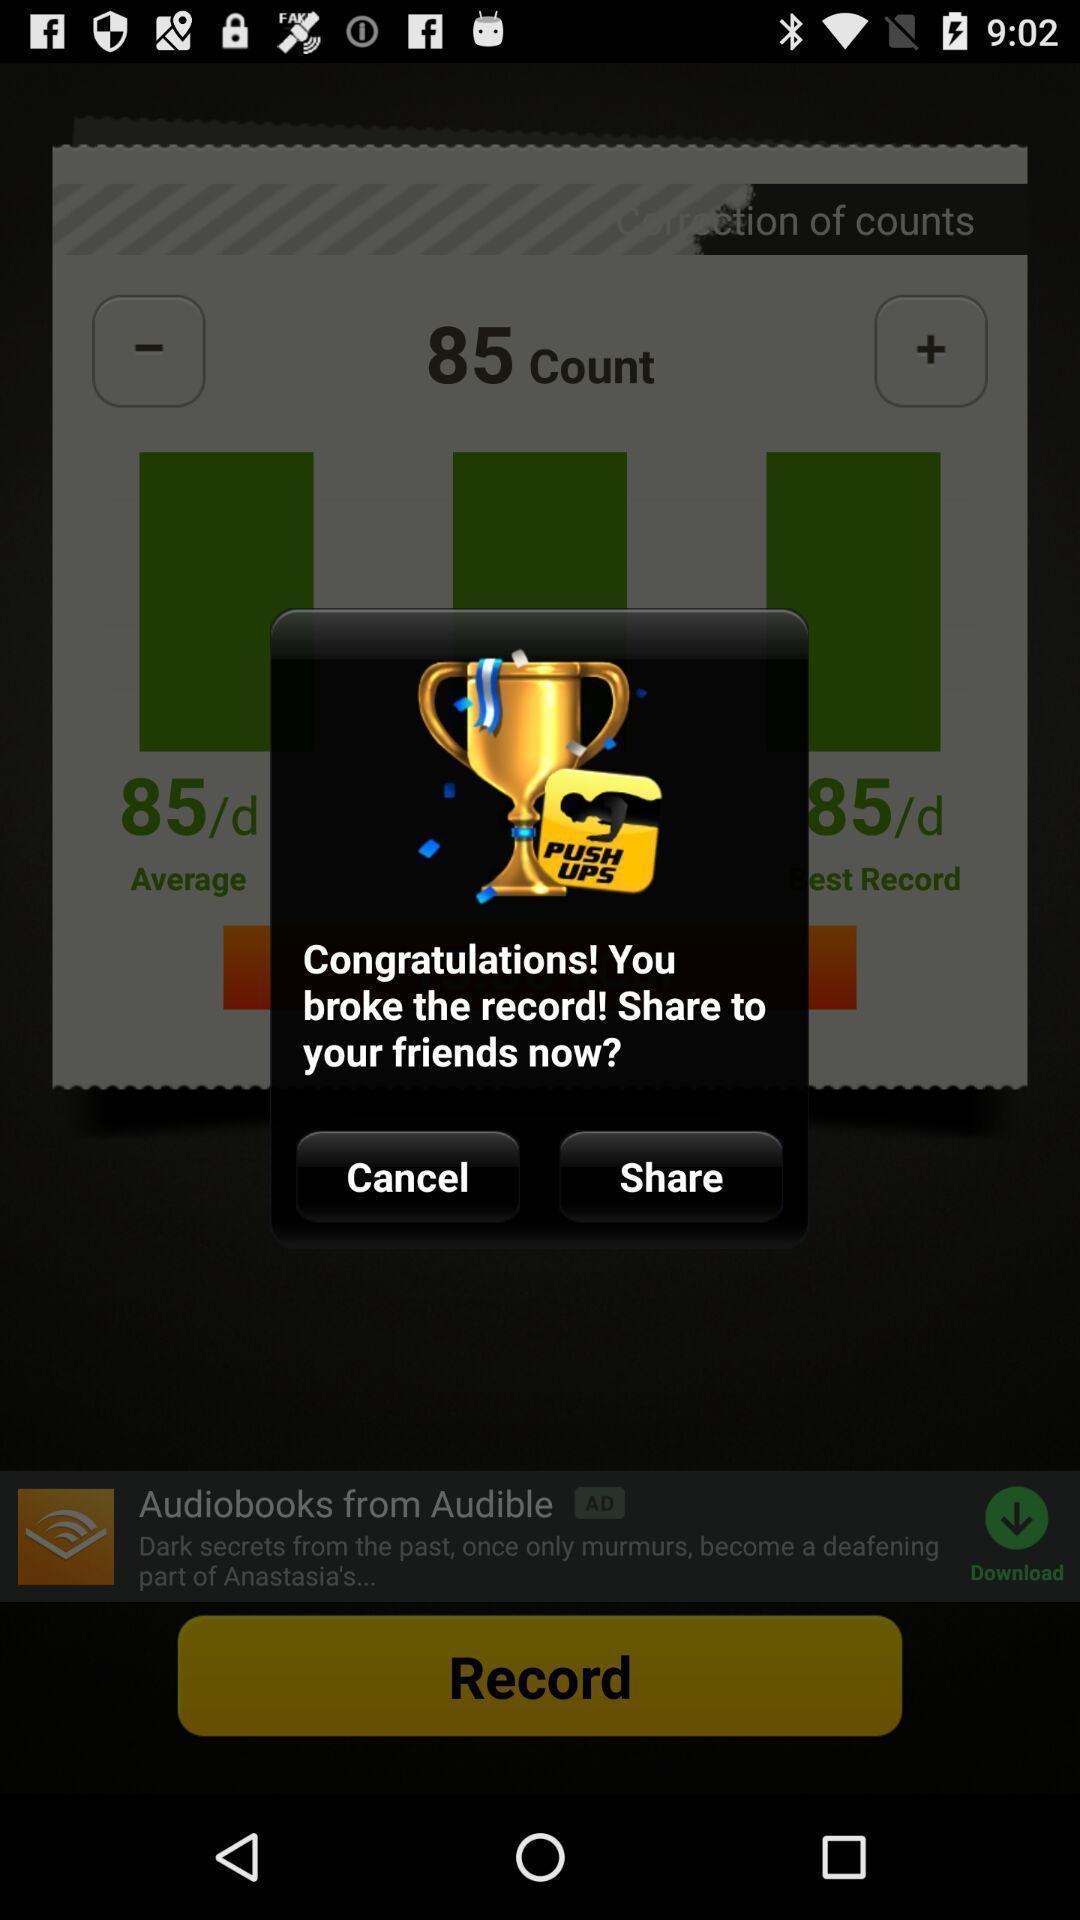Provide a detailed account of this screenshot. Pop-up showing information to share. 